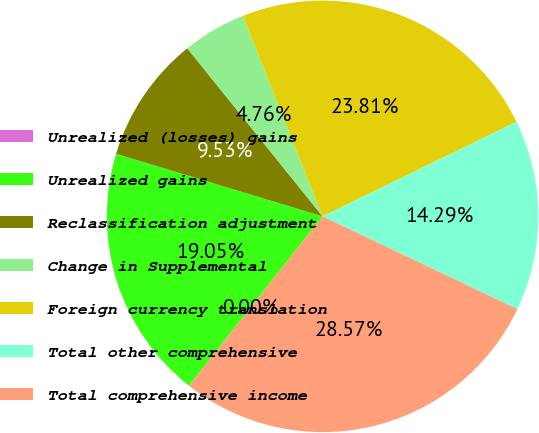<chart> <loc_0><loc_0><loc_500><loc_500><pie_chart><fcel>Unrealized (losses) gains<fcel>Unrealized gains<fcel>Reclassification adjustment<fcel>Change in Supplemental<fcel>Foreign currency translation<fcel>Total other comprehensive<fcel>Total comprehensive income<nl><fcel>0.0%<fcel>19.05%<fcel>9.53%<fcel>4.76%<fcel>23.81%<fcel>14.29%<fcel>28.57%<nl></chart> 